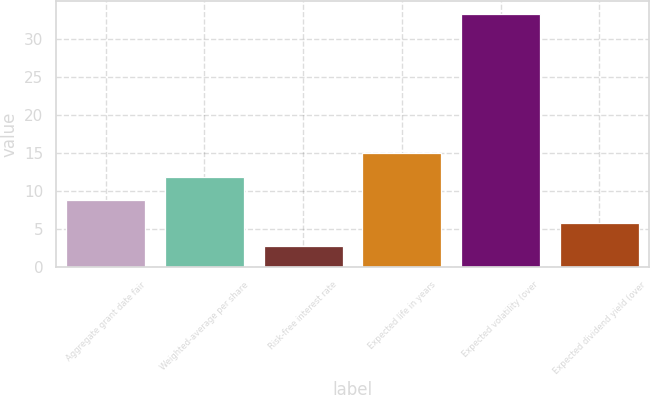Convert chart to OTSL. <chart><loc_0><loc_0><loc_500><loc_500><bar_chart><fcel>Aggregate grant date fair<fcel>Weighted-average per share<fcel>Risk-free interest rate<fcel>Expected life in years<fcel>Expected volatility (over<fcel>Expected dividend yield (over<nl><fcel>8.82<fcel>11.88<fcel>2.7<fcel>14.94<fcel>33.3<fcel>5.76<nl></chart> 